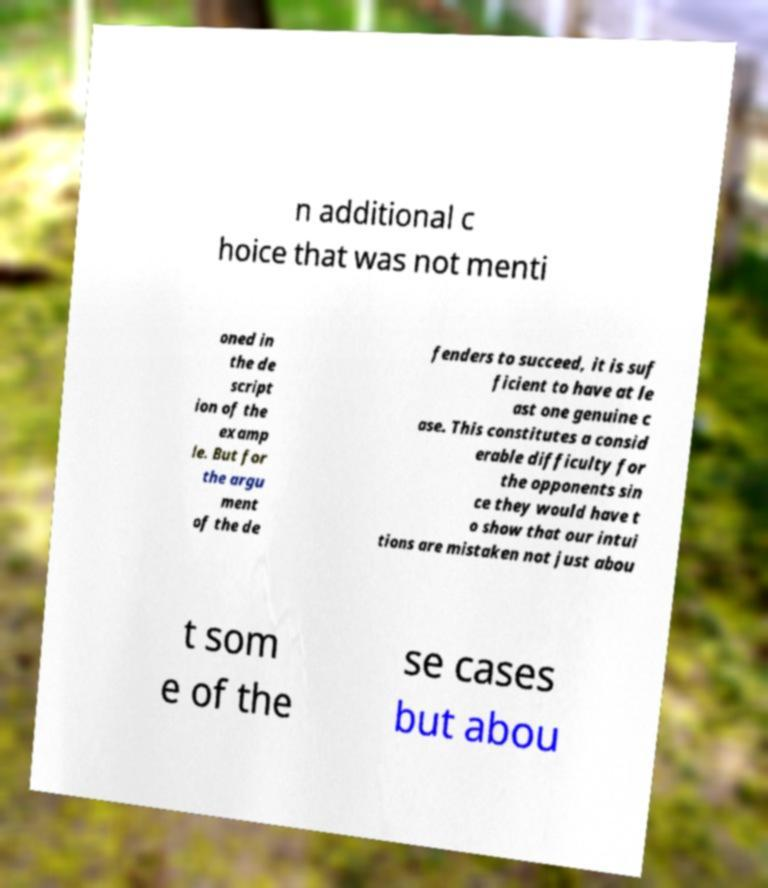I need the written content from this picture converted into text. Can you do that? n additional c hoice that was not menti oned in the de script ion of the examp le. But for the argu ment of the de fenders to succeed, it is suf ficient to have at le ast one genuine c ase. This constitutes a consid erable difficulty for the opponents sin ce they would have t o show that our intui tions are mistaken not just abou t som e of the se cases but abou 